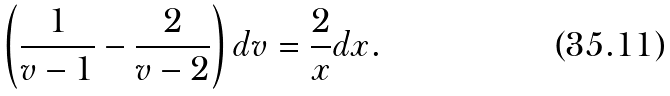<formula> <loc_0><loc_0><loc_500><loc_500>\left ( \frac { 1 } { v - 1 } - \frac { 2 } { v - 2 } \right ) d v = \frac { 2 } { x } d x .</formula> 